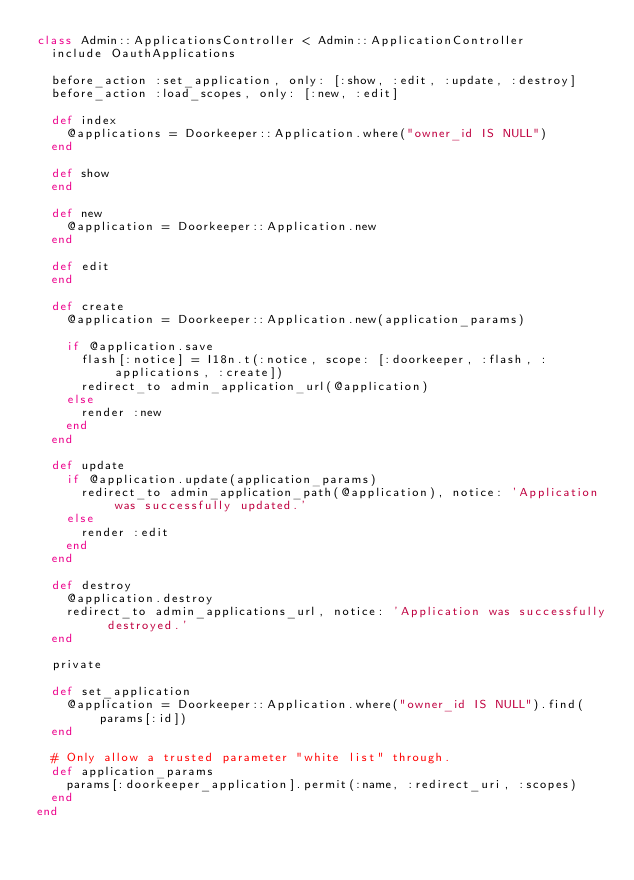<code> <loc_0><loc_0><loc_500><loc_500><_Ruby_>class Admin::ApplicationsController < Admin::ApplicationController
  include OauthApplications

  before_action :set_application, only: [:show, :edit, :update, :destroy]
  before_action :load_scopes, only: [:new, :edit]

  def index
    @applications = Doorkeeper::Application.where("owner_id IS NULL")
  end

  def show
  end

  def new
    @application = Doorkeeper::Application.new
  end

  def edit
  end

  def create
    @application = Doorkeeper::Application.new(application_params)

    if @application.save
      flash[:notice] = I18n.t(:notice, scope: [:doorkeeper, :flash, :applications, :create])
      redirect_to admin_application_url(@application)
    else
      render :new
    end
  end

  def update
    if @application.update(application_params)
      redirect_to admin_application_path(@application), notice: 'Application was successfully updated.'
    else
      render :edit
    end
  end

  def destroy
    @application.destroy
    redirect_to admin_applications_url, notice: 'Application was successfully destroyed.'
  end

  private

  def set_application
    @application = Doorkeeper::Application.where("owner_id IS NULL").find(params[:id])
  end

  # Only allow a trusted parameter "white list" through.
  def application_params
    params[:doorkeeper_application].permit(:name, :redirect_uri, :scopes)
  end
end
</code> 